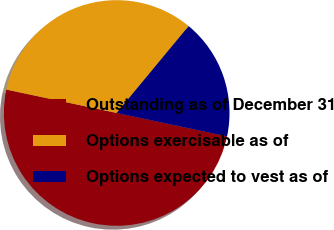<chart> <loc_0><loc_0><loc_500><loc_500><pie_chart><fcel>Outstanding as of December 31<fcel>Options exercisable as of<fcel>Options expected to vest as of<nl><fcel>50.0%<fcel>32.69%<fcel>17.31%<nl></chart> 